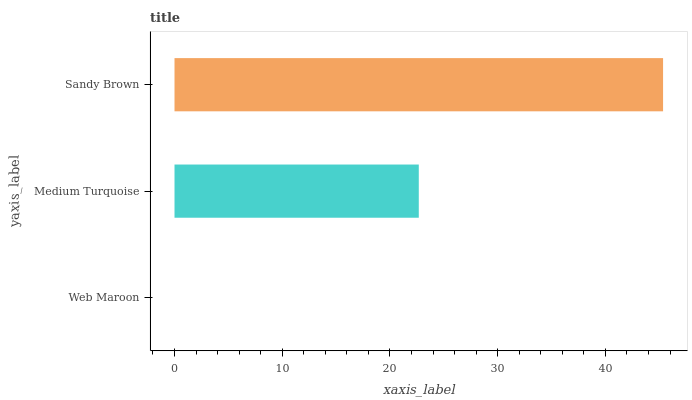Is Web Maroon the minimum?
Answer yes or no. Yes. Is Sandy Brown the maximum?
Answer yes or no. Yes. Is Medium Turquoise the minimum?
Answer yes or no. No. Is Medium Turquoise the maximum?
Answer yes or no. No. Is Medium Turquoise greater than Web Maroon?
Answer yes or no. Yes. Is Web Maroon less than Medium Turquoise?
Answer yes or no. Yes. Is Web Maroon greater than Medium Turquoise?
Answer yes or no. No. Is Medium Turquoise less than Web Maroon?
Answer yes or no. No. Is Medium Turquoise the high median?
Answer yes or no. Yes. Is Medium Turquoise the low median?
Answer yes or no. Yes. Is Web Maroon the high median?
Answer yes or no. No. Is Web Maroon the low median?
Answer yes or no. No. 